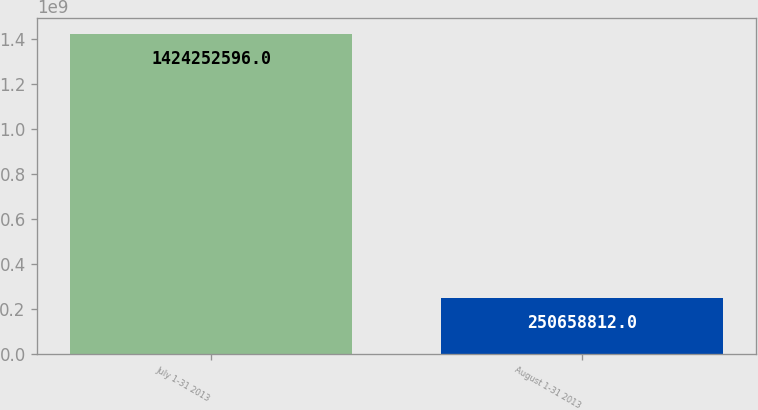Convert chart. <chart><loc_0><loc_0><loc_500><loc_500><bar_chart><fcel>July 1-31 2013<fcel>August 1-31 2013<nl><fcel>1.42425e+09<fcel>2.50659e+08<nl></chart> 